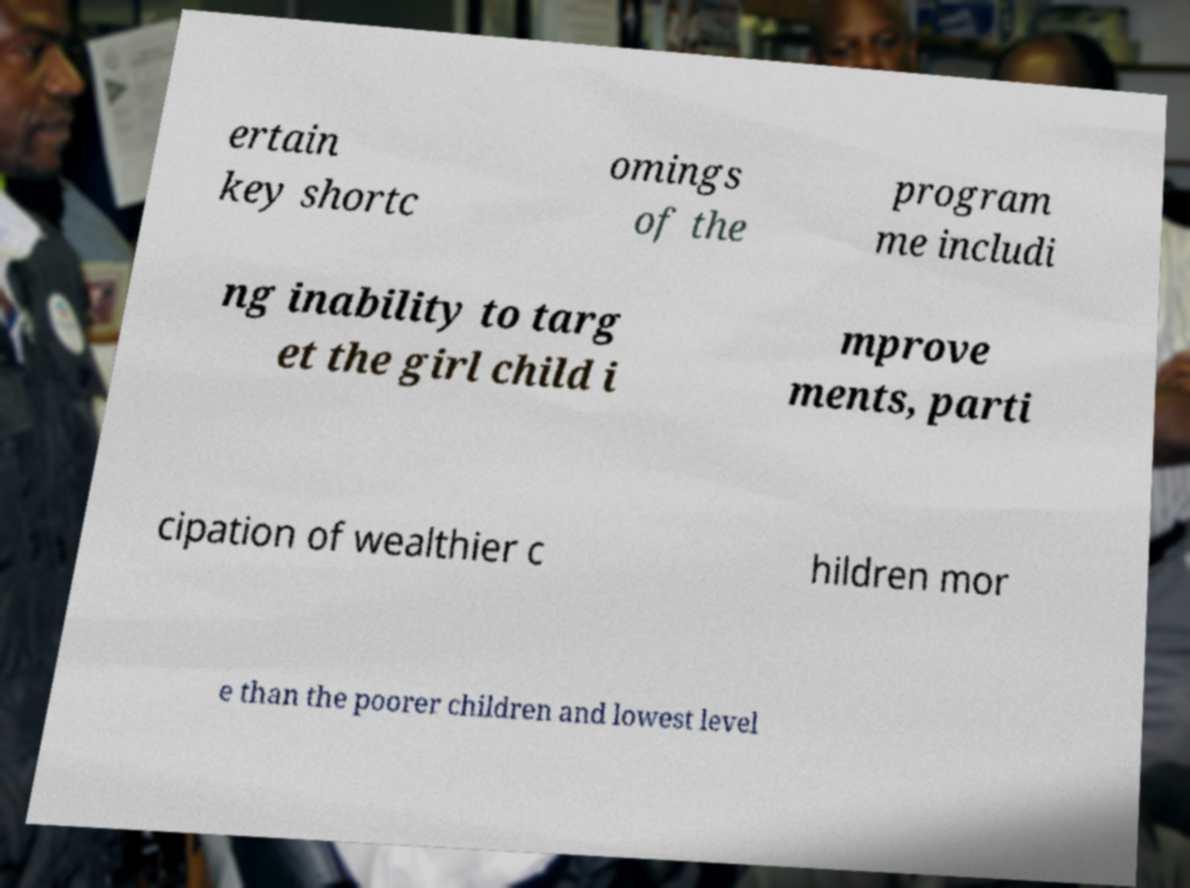There's text embedded in this image that I need extracted. Can you transcribe it verbatim? ertain key shortc omings of the program me includi ng inability to targ et the girl child i mprove ments, parti cipation of wealthier c hildren mor e than the poorer children and lowest level 